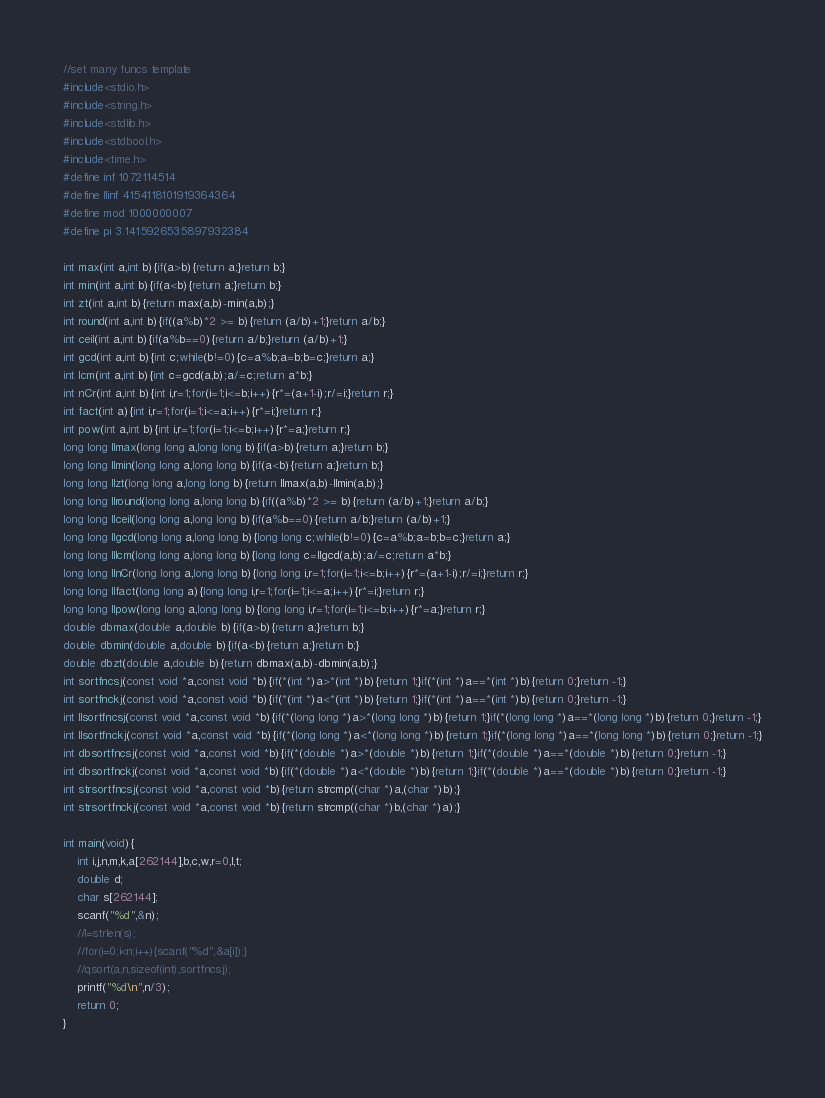Convert code to text. <code><loc_0><loc_0><loc_500><loc_500><_C_>//set many funcs template
#include<stdio.h>
#include<string.h>
#include<stdlib.h>
#include<stdbool.h>
#include<time.h>
#define inf 1072114514
#define llinf 4154118101919364364
#define mod 1000000007
#define pi 3.1415926535897932384

int max(int a,int b){if(a>b){return a;}return b;}
int min(int a,int b){if(a<b){return a;}return b;}
int zt(int a,int b){return max(a,b)-min(a,b);}
int round(int a,int b){if((a%b)*2 >= b){return (a/b)+1;}return a/b;}
int ceil(int a,int b){if(a%b==0){return a/b;}return (a/b)+1;}
int gcd(int a,int b){int c;while(b!=0){c=a%b;a=b;b=c;}return a;}
int lcm(int a,int b){int c=gcd(a,b);a/=c;return a*b;}
int nCr(int a,int b){int i,r=1;for(i=1;i<=b;i++){r*=(a+1-i);r/=i;}return r;}
int fact(int a){int i,r=1;for(i=1;i<=a;i++){r*=i;}return r;}
int pow(int a,int b){int i,r=1;for(i=1;i<=b;i++){r*=a;}return r;}
long long llmax(long long a,long long b){if(a>b){return a;}return b;}
long long llmin(long long a,long long b){if(a<b){return a;}return b;}
long long llzt(long long a,long long b){return llmax(a,b)-llmin(a,b);}
long long llround(long long a,long long b){if((a%b)*2 >= b){return (a/b)+1;}return a/b;}
long long llceil(long long a,long long b){if(a%b==0){return a/b;}return (a/b)+1;}
long long llgcd(long long a,long long b){long long c;while(b!=0){c=a%b;a=b;b=c;}return a;}
long long lllcm(long long a,long long b){long long c=llgcd(a,b);a/=c;return a*b;}
long long llnCr(long long a,long long b){long long i,r=1;for(i=1;i<=b;i++){r*=(a+1-i);r/=i;}return r;}
long long llfact(long long a){long long i,r=1;for(i=1;i<=a;i++){r*=i;}return r;}
long long llpow(long long a,long long b){long long i,r=1;for(i=1;i<=b;i++){r*=a;}return r;}
double dbmax(double a,double b){if(a>b){return a;}return b;}
double dbmin(double a,double b){if(a<b){return a;}return b;}
double dbzt(double a,double b){return dbmax(a,b)-dbmin(a,b);}
int sortfncsj(const void *a,const void *b){if(*(int *)a>*(int *)b){return 1;}if(*(int *)a==*(int *)b){return 0;}return -1;}
int sortfnckj(const void *a,const void *b){if(*(int *)a<*(int *)b){return 1;}if(*(int *)a==*(int *)b){return 0;}return -1;}
int llsortfncsj(const void *a,const void *b){if(*(long long *)a>*(long long *)b){return 1;}if(*(long long *)a==*(long long *)b){return 0;}return -1;}
int llsortfnckj(const void *a,const void *b){if(*(long long *)a<*(long long *)b){return 1;}if(*(long long *)a==*(long long *)b){return 0;}return -1;}
int dbsortfncsj(const void *a,const void *b){if(*(double *)a>*(double *)b){return 1;}if(*(double *)a==*(double *)b){return 0;}return -1;}
int dbsortfnckj(const void *a,const void *b){if(*(double *)a<*(double *)b){return 1;}if(*(double *)a==*(double *)b){return 0;}return -1;}
int strsortfncsj(const void *a,const void *b){return strcmp((char *)a,(char *)b);}
int strsortfnckj(const void *a,const void *b){return strcmp((char *)b,(char *)a);}

int main(void){
    int i,j,n,m,k,a[262144],b,c,w,r=0,l,t;
    double d;
    char s[262144];
    scanf("%d",&n);
    //l=strlen(s);
    //for(i=0;i<n;i++){scanf("%d",&a[i]);}
    //qsort(a,n,sizeof(int),sortfncsj);
    printf("%d\n",n/3);
    return 0;
}</code> 